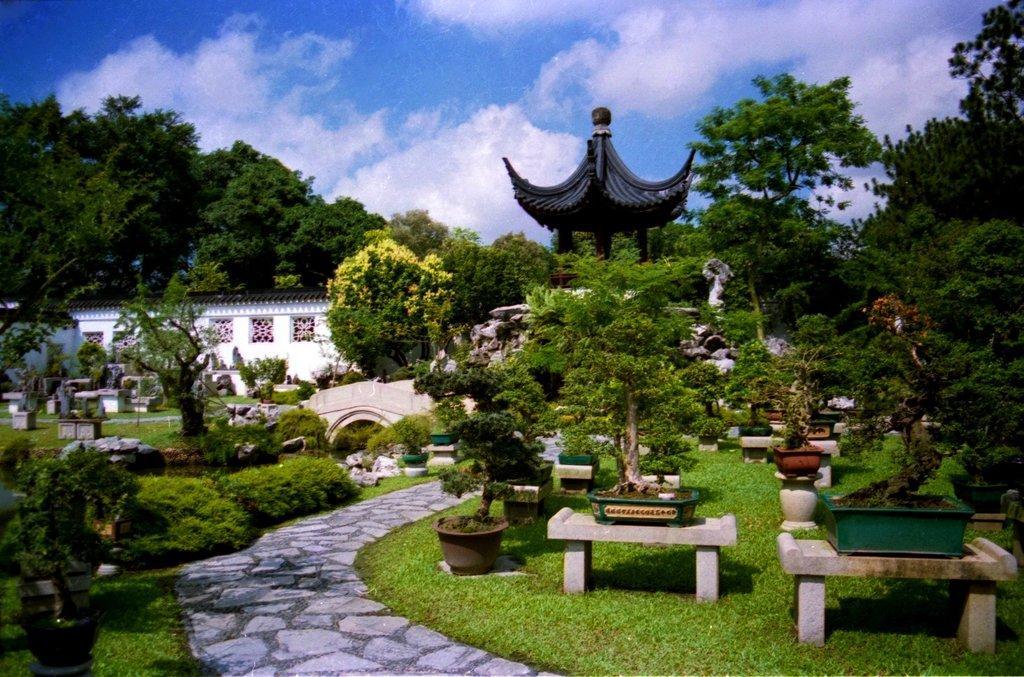In one or two sentences, can you explain what this image depicts? In this image in front there are tables. On top of it there are flower pots. At the bottom of the image there is grass on the surface. In the background of the image there is a building. There are rocks. There are trees. At the top of the image there is sky. 